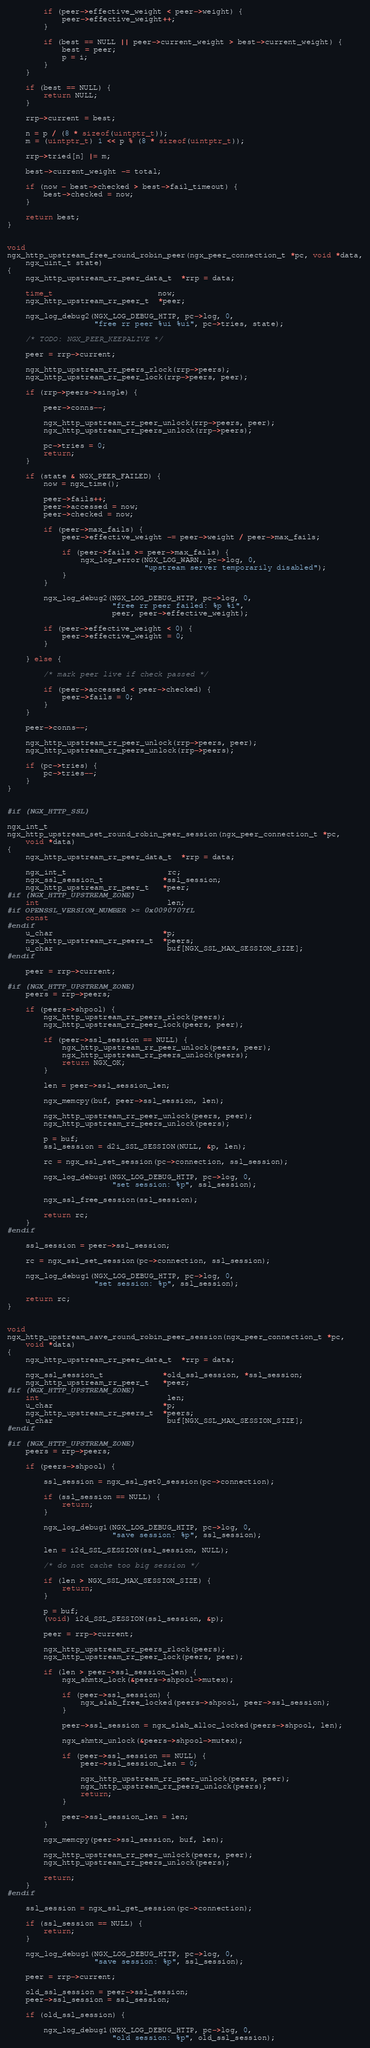<code> <loc_0><loc_0><loc_500><loc_500><_C_>        if (peer->effective_weight < peer->weight) {
            peer->effective_weight++;
        }

        if (best == NULL || peer->current_weight > best->current_weight) {
            best = peer;
            p = i;
        }
    }

    if (best == NULL) {
        return NULL;
    }

    rrp->current = best;

    n = p / (8 * sizeof(uintptr_t));
    m = (uintptr_t) 1 << p % (8 * sizeof(uintptr_t));

    rrp->tried[n] |= m;

    best->current_weight -= total;

    if (now - best->checked > best->fail_timeout) {
        best->checked = now;
    }

    return best;
}


void
ngx_http_upstream_free_round_robin_peer(ngx_peer_connection_t *pc, void *data,
    ngx_uint_t state)
{
    ngx_http_upstream_rr_peer_data_t  *rrp = data;

    time_t                       now;
    ngx_http_upstream_rr_peer_t  *peer;

    ngx_log_debug2(NGX_LOG_DEBUG_HTTP, pc->log, 0,
                   "free rr peer %ui %ui", pc->tries, state);

    /* TODO: NGX_PEER_KEEPALIVE */

    peer = rrp->current;

    ngx_http_upstream_rr_peers_rlock(rrp->peers);
    ngx_http_upstream_rr_peer_lock(rrp->peers, peer);

    if (rrp->peers->single) {

        peer->conns--;

        ngx_http_upstream_rr_peer_unlock(rrp->peers, peer);
        ngx_http_upstream_rr_peers_unlock(rrp->peers);

        pc->tries = 0;
        return;
    }

    if (state & NGX_PEER_FAILED) {
        now = ngx_time();

        peer->fails++;
        peer->accessed = now;
        peer->checked = now;

        if (peer->max_fails) {
            peer->effective_weight -= peer->weight / peer->max_fails;

            if (peer->fails >= peer->max_fails) {
                ngx_log_error(NGX_LOG_WARN, pc->log, 0,
                              "upstream server temporarily disabled");
            }
        }

        ngx_log_debug2(NGX_LOG_DEBUG_HTTP, pc->log, 0,
                       "free rr peer failed: %p %i",
                       peer, peer->effective_weight);

        if (peer->effective_weight < 0) {
            peer->effective_weight = 0;
        }

    } else {

        /* mark peer live if check passed */

        if (peer->accessed < peer->checked) {
            peer->fails = 0;
        }
    }

    peer->conns--;

    ngx_http_upstream_rr_peer_unlock(rrp->peers, peer);
    ngx_http_upstream_rr_peers_unlock(rrp->peers);

    if (pc->tries) {
        pc->tries--;
    }
}


#if (NGX_HTTP_SSL)

ngx_int_t
ngx_http_upstream_set_round_robin_peer_session(ngx_peer_connection_t *pc,
    void *data)
{
    ngx_http_upstream_rr_peer_data_t  *rrp = data;

    ngx_int_t                      rc;
    ngx_ssl_session_t             *ssl_session;
    ngx_http_upstream_rr_peer_t   *peer;
#if (NGX_HTTP_UPSTREAM_ZONE)
    int                            len;
#if OPENSSL_VERSION_NUMBER >= 0x0090707fL
    const
#endif
    u_char                        *p;
    ngx_http_upstream_rr_peers_t  *peers;
    u_char                         buf[NGX_SSL_MAX_SESSION_SIZE];
#endif

    peer = rrp->current;

#if (NGX_HTTP_UPSTREAM_ZONE)
    peers = rrp->peers;

    if (peers->shpool) {
        ngx_http_upstream_rr_peers_rlock(peers);
        ngx_http_upstream_rr_peer_lock(peers, peer);

        if (peer->ssl_session == NULL) {
            ngx_http_upstream_rr_peer_unlock(peers, peer);
            ngx_http_upstream_rr_peers_unlock(peers);
            return NGX_OK;
        }

        len = peer->ssl_session_len;

        ngx_memcpy(buf, peer->ssl_session, len);

        ngx_http_upstream_rr_peer_unlock(peers, peer);
        ngx_http_upstream_rr_peers_unlock(peers);

        p = buf;
        ssl_session = d2i_SSL_SESSION(NULL, &p, len);

        rc = ngx_ssl_set_session(pc->connection, ssl_session);

        ngx_log_debug1(NGX_LOG_DEBUG_HTTP, pc->log, 0,
                       "set session: %p", ssl_session);

        ngx_ssl_free_session(ssl_session);

        return rc;
    }
#endif

    ssl_session = peer->ssl_session;

    rc = ngx_ssl_set_session(pc->connection, ssl_session);

    ngx_log_debug1(NGX_LOG_DEBUG_HTTP, pc->log, 0,
                   "set session: %p", ssl_session);

    return rc;
}


void
ngx_http_upstream_save_round_robin_peer_session(ngx_peer_connection_t *pc,
    void *data)
{
    ngx_http_upstream_rr_peer_data_t  *rrp = data;

    ngx_ssl_session_t             *old_ssl_session, *ssl_session;
    ngx_http_upstream_rr_peer_t   *peer;
#if (NGX_HTTP_UPSTREAM_ZONE)
    int                            len;
    u_char                        *p;
    ngx_http_upstream_rr_peers_t  *peers;
    u_char                         buf[NGX_SSL_MAX_SESSION_SIZE];
#endif

#if (NGX_HTTP_UPSTREAM_ZONE)
    peers = rrp->peers;

    if (peers->shpool) {

        ssl_session = ngx_ssl_get0_session(pc->connection);

        if (ssl_session == NULL) {
            return;
        }

        ngx_log_debug1(NGX_LOG_DEBUG_HTTP, pc->log, 0,
                       "save session: %p", ssl_session);

        len = i2d_SSL_SESSION(ssl_session, NULL);

        /* do not cache too big session */

        if (len > NGX_SSL_MAX_SESSION_SIZE) {
            return;
        }

        p = buf;
        (void) i2d_SSL_SESSION(ssl_session, &p);

        peer = rrp->current;

        ngx_http_upstream_rr_peers_rlock(peers);
        ngx_http_upstream_rr_peer_lock(peers, peer);

        if (len > peer->ssl_session_len) {
            ngx_shmtx_lock(&peers->shpool->mutex);

            if (peer->ssl_session) {
                ngx_slab_free_locked(peers->shpool, peer->ssl_session);
            }

            peer->ssl_session = ngx_slab_alloc_locked(peers->shpool, len);

            ngx_shmtx_unlock(&peers->shpool->mutex);

            if (peer->ssl_session == NULL) {
                peer->ssl_session_len = 0;

                ngx_http_upstream_rr_peer_unlock(peers, peer);
                ngx_http_upstream_rr_peers_unlock(peers);
                return;
            }

            peer->ssl_session_len = len;
        }

        ngx_memcpy(peer->ssl_session, buf, len);

        ngx_http_upstream_rr_peer_unlock(peers, peer);
        ngx_http_upstream_rr_peers_unlock(peers);

        return;
    }
#endif

    ssl_session = ngx_ssl_get_session(pc->connection);

    if (ssl_session == NULL) {
        return;
    }

    ngx_log_debug1(NGX_LOG_DEBUG_HTTP, pc->log, 0,
                   "save session: %p", ssl_session);

    peer = rrp->current;

    old_ssl_session = peer->ssl_session;
    peer->ssl_session = ssl_session;

    if (old_ssl_session) {

        ngx_log_debug1(NGX_LOG_DEBUG_HTTP, pc->log, 0,
                       "old session: %p", old_ssl_session);
</code> 